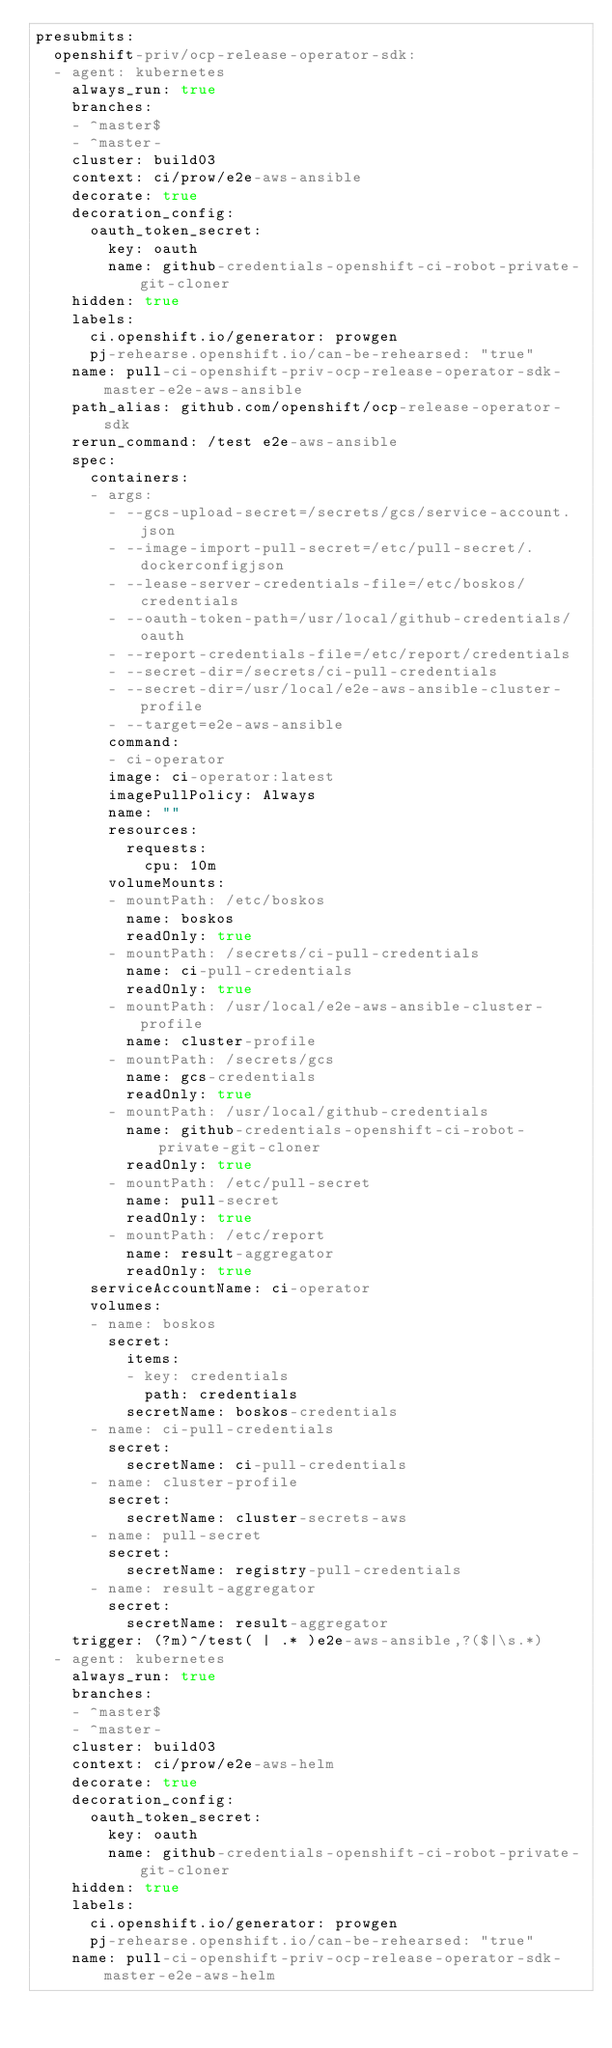<code> <loc_0><loc_0><loc_500><loc_500><_YAML_>presubmits:
  openshift-priv/ocp-release-operator-sdk:
  - agent: kubernetes
    always_run: true
    branches:
    - ^master$
    - ^master-
    cluster: build03
    context: ci/prow/e2e-aws-ansible
    decorate: true
    decoration_config:
      oauth_token_secret:
        key: oauth
        name: github-credentials-openshift-ci-robot-private-git-cloner
    hidden: true
    labels:
      ci.openshift.io/generator: prowgen
      pj-rehearse.openshift.io/can-be-rehearsed: "true"
    name: pull-ci-openshift-priv-ocp-release-operator-sdk-master-e2e-aws-ansible
    path_alias: github.com/openshift/ocp-release-operator-sdk
    rerun_command: /test e2e-aws-ansible
    spec:
      containers:
      - args:
        - --gcs-upload-secret=/secrets/gcs/service-account.json
        - --image-import-pull-secret=/etc/pull-secret/.dockerconfigjson
        - --lease-server-credentials-file=/etc/boskos/credentials
        - --oauth-token-path=/usr/local/github-credentials/oauth
        - --report-credentials-file=/etc/report/credentials
        - --secret-dir=/secrets/ci-pull-credentials
        - --secret-dir=/usr/local/e2e-aws-ansible-cluster-profile
        - --target=e2e-aws-ansible
        command:
        - ci-operator
        image: ci-operator:latest
        imagePullPolicy: Always
        name: ""
        resources:
          requests:
            cpu: 10m
        volumeMounts:
        - mountPath: /etc/boskos
          name: boskos
          readOnly: true
        - mountPath: /secrets/ci-pull-credentials
          name: ci-pull-credentials
          readOnly: true
        - mountPath: /usr/local/e2e-aws-ansible-cluster-profile
          name: cluster-profile
        - mountPath: /secrets/gcs
          name: gcs-credentials
          readOnly: true
        - mountPath: /usr/local/github-credentials
          name: github-credentials-openshift-ci-robot-private-git-cloner
          readOnly: true
        - mountPath: /etc/pull-secret
          name: pull-secret
          readOnly: true
        - mountPath: /etc/report
          name: result-aggregator
          readOnly: true
      serviceAccountName: ci-operator
      volumes:
      - name: boskos
        secret:
          items:
          - key: credentials
            path: credentials
          secretName: boskos-credentials
      - name: ci-pull-credentials
        secret:
          secretName: ci-pull-credentials
      - name: cluster-profile
        secret:
          secretName: cluster-secrets-aws
      - name: pull-secret
        secret:
          secretName: registry-pull-credentials
      - name: result-aggregator
        secret:
          secretName: result-aggregator
    trigger: (?m)^/test( | .* )e2e-aws-ansible,?($|\s.*)
  - agent: kubernetes
    always_run: true
    branches:
    - ^master$
    - ^master-
    cluster: build03
    context: ci/prow/e2e-aws-helm
    decorate: true
    decoration_config:
      oauth_token_secret:
        key: oauth
        name: github-credentials-openshift-ci-robot-private-git-cloner
    hidden: true
    labels:
      ci.openshift.io/generator: prowgen
      pj-rehearse.openshift.io/can-be-rehearsed: "true"
    name: pull-ci-openshift-priv-ocp-release-operator-sdk-master-e2e-aws-helm</code> 